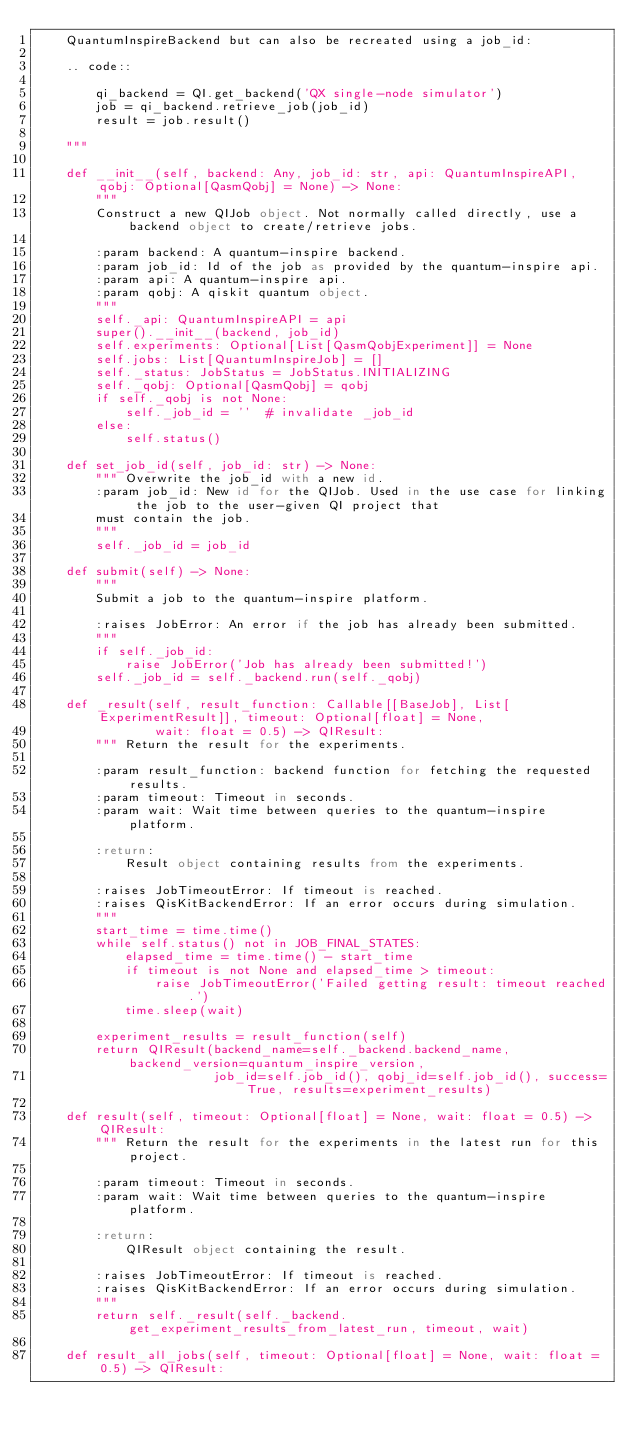<code> <loc_0><loc_0><loc_500><loc_500><_Python_>    QuantumInspireBackend but can also be recreated using a job_id:

    .. code::

        qi_backend = QI.get_backend('QX single-node simulator')
        job = qi_backend.retrieve_job(job_id)
        result = job.result()

    """

    def __init__(self, backend: Any, job_id: str, api: QuantumInspireAPI, qobj: Optional[QasmQobj] = None) -> None:
        """
        Construct a new QIJob object. Not normally called directly, use a backend object to create/retrieve jobs.

        :param backend: A quantum-inspire backend.
        :param job_id: Id of the job as provided by the quantum-inspire api.
        :param api: A quantum-inspire api.
        :param qobj: A qiskit quantum object.
        """
        self._api: QuantumInspireAPI = api
        super().__init__(backend, job_id)
        self.experiments: Optional[List[QasmQobjExperiment]] = None
        self.jobs: List[QuantumInspireJob] = []
        self._status: JobStatus = JobStatus.INITIALIZING
        self._qobj: Optional[QasmQobj] = qobj
        if self._qobj is not None:
            self._job_id = ''  # invalidate _job_id
        else:
            self.status()

    def set_job_id(self, job_id: str) -> None:
        """ Overwrite the job_id with a new id.
        :param job_id: New id for the QIJob. Used in the use case for linking the job to the user-given QI project that
        must contain the job.
        """
        self._job_id = job_id

    def submit(self) -> None:
        """
        Submit a job to the quantum-inspire platform.

        :raises JobError: An error if the job has already been submitted.
        """
        if self._job_id:
            raise JobError('Job has already been submitted!')
        self._job_id = self._backend.run(self._qobj)

    def _result(self, result_function: Callable[[BaseJob], List[ExperimentResult]], timeout: Optional[float] = None,
                wait: float = 0.5) -> QIResult:
        """ Return the result for the experiments.

        :param result_function: backend function for fetching the requested results.
        :param timeout: Timeout in seconds.
        :param wait: Wait time between queries to the quantum-inspire platform.

        :return:
            Result object containing results from the experiments.

        :raises JobTimeoutError: If timeout is reached.
        :raises QisKitBackendError: If an error occurs during simulation.
        """
        start_time = time.time()
        while self.status() not in JOB_FINAL_STATES:
            elapsed_time = time.time() - start_time
            if timeout is not None and elapsed_time > timeout:
                raise JobTimeoutError('Failed getting result: timeout reached.')
            time.sleep(wait)

        experiment_results = result_function(self)
        return QIResult(backend_name=self._backend.backend_name, backend_version=quantum_inspire_version,
                        job_id=self.job_id(), qobj_id=self.job_id(), success=True, results=experiment_results)

    def result(self, timeout: Optional[float] = None, wait: float = 0.5) -> QIResult:
        """ Return the result for the experiments in the latest run for this project.

        :param timeout: Timeout in seconds.
        :param wait: Wait time between queries to the quantum-inspire platform.

        :return:
            QIResult object containing the result.

        :raises JobTimeoutError: If timeout is reached.
        :raises QisKitBackendError: If an error occurs during simulation.
        """
        return self._result(self._backend.get_experiment_results_from_latest_run, timeout, wait)

    def result_all_jobs(self, timeout: Optional[float] = None, wait: float = 0.5) -> QIResult:</code> 